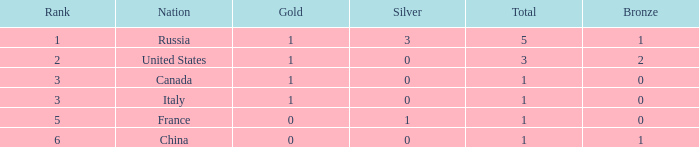Name the total number of golds when total is 1 and silver is 1 1.0. 